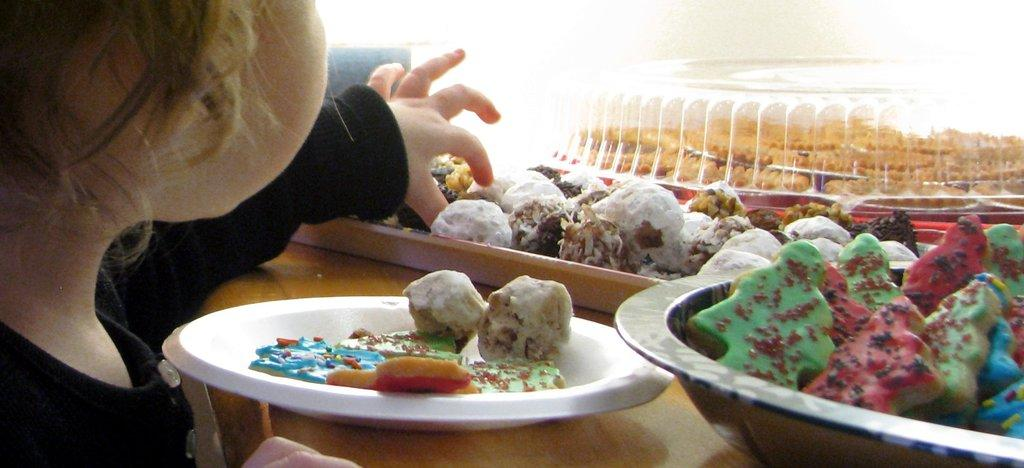Who or what is present in the image? There is a person in the image. What else can be seen in the image besides the person? There are food items, a bowl, a tray, and a plate in the image. How are the food items arranged in the image? The food items are placed on a platform in the image. What type of event is taking place in the image? There is no indication of an event taking place in the image. What season is depicted in the image? The provided facts do not mention any seasonal details, so it cannot be determined from the image. 